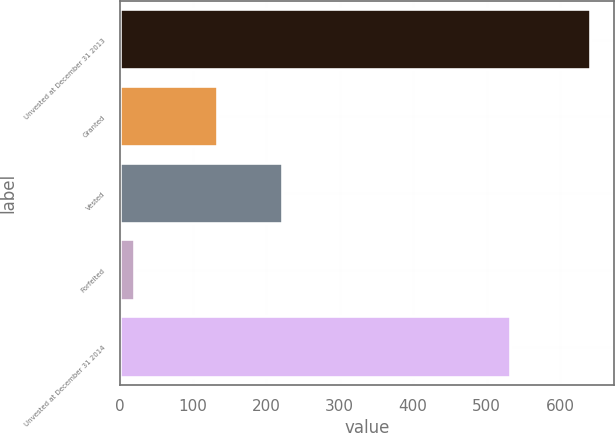<chart> <loc_0><loc_0><loc_500><loc_500><bar_chart><fcel>Unvested at December 31 2013<fcel>Granted<fcel>Vested<fcel>Forfeited<fcel>Unvested at December 31 2014<nl><fcel>642<fcel>134<fcel>222<fcel>21<fcel>533<nl></chart> 